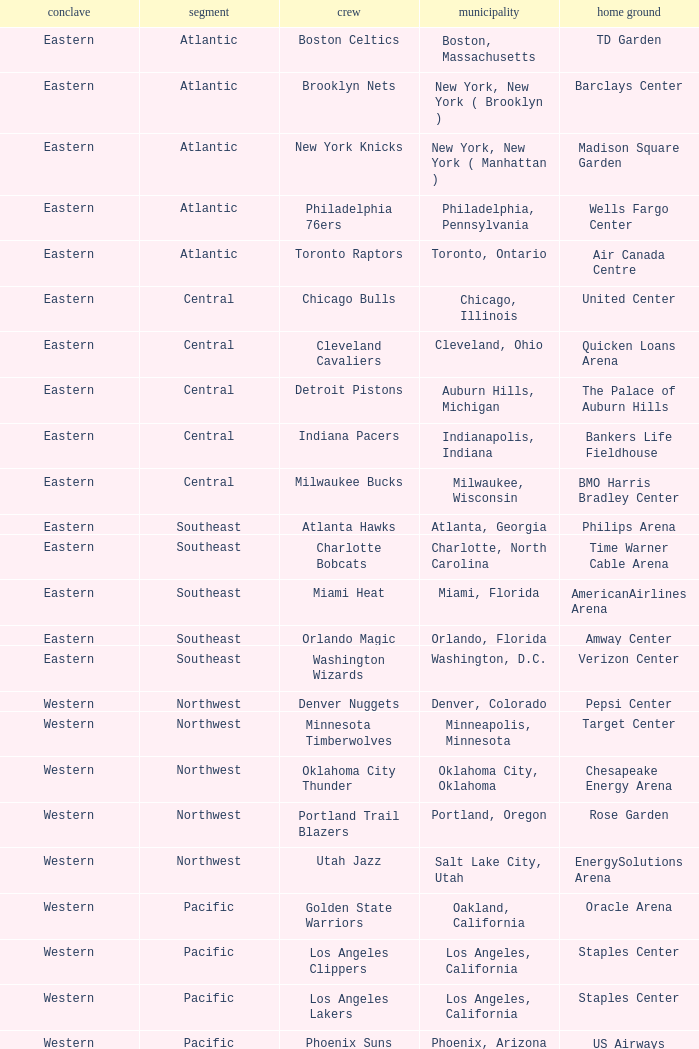Which city includes Barclays Center? New York, New York ( Brooklyn ). 